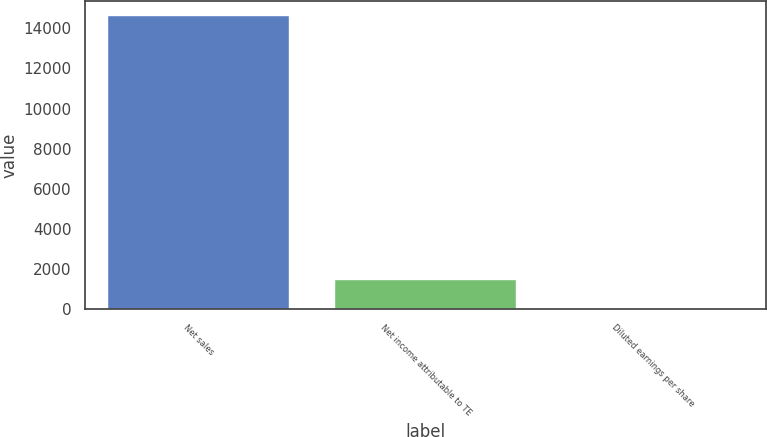Convert chart to OTSL. <chart><loc_0><loc_0><loc_500><loc_500><bar_chart><fcel>Net sales<fcel>Net income attributable to TE<fcel>Diluted earnings per share<nl><fcel>14612<fcel>1463.69<fcel>2.77<nl></chart> 